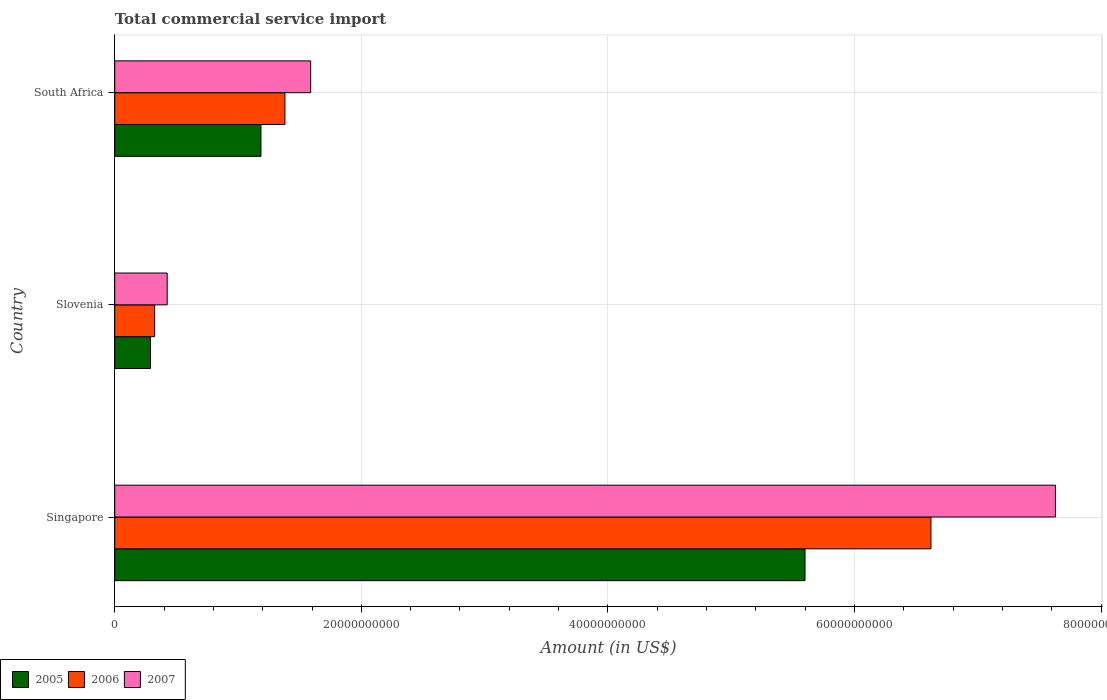How many different coloured bars are there?
Your answer should be compact. 3. Are the number of bars per tick equal to the number of legend labels?
Provide a short and direct response. Yes. How many bars are there on the 3rd tick from the bottom?
Your answer should be very brief. 3. What is the label of the 2nd group of bars from the top?
Ensure brevity in your answer.  Slovenia. In how many cases, is the number of bars for a given country not equal to the number of legend labels?
Ensure brevity in your answer.  0. What is the total commercial service import in 2007 in Singapore?
Keep it short and to the point. 7.63e+1. Across all countries, what is the maximum total commercial service import in 2006?
Offer a terse response. 6.62e+1. Across all countries, what is the minimum total commercial service import in 2007?
Your response must be concise. 4.25e+09. In which country was the total commercial service import in 2006 maximum?
Offer a very short reply. Singapore. In which country was the total commercial service import in 2005 minimum?
Provide a succinct answer. Slovenia. What is the total total commercial service import in 2005 in the graph?
Your answer should be compact. 7.07e+1. What is the difference between the total commercial service import in 2007 in Singapore and that in South Africa?
Keep it short and to the point. 6.04e+1. What is the difference between the total commercial service import in 2007 in Singapore and the total commercial service import in 2005 in Slovenia?
Offer a very short reply. 7.34e+1. What is the average total commercial service import in 2005 per country?
Ensure brevity in your answer.  2.36e+1. What is the difference between the total commercial service import in 2006 and total commercial service import in 2005 in South Africa?
Your response must be concise. 1.94e+09. In how many countries, is the total commercial service import in 2005 greater than 4000000000 US$?
Ensure brevity in your answer.  2. What is the ratio of the total commercial service import in 2005 in Singapore to that in South Africa?
Offer a terse response. 4.72. What is the difference between the highest and the second highest total commercial service import in 2006?
Your answer should be very brief. 5.24e+1. What is the difference between the highest and the lowest total commercial service import in 2005?
Your answer should be very brief. 5.31e+1. In how many countries, is the total commercial service import in 2006 greater than the average total commercial service import in 2006 taken over all countries?
Give a very brief answer. 1. Is the sum of the total commercial service import in 2007 in Slovenia and South Africa greater than the maximum total commercial service import in 2005 across all countries?
Offer a very short reply. No. What does the 1st bar from the bottom in Singapore represents?
Make the answer very short. 2005. Is it the case that in every country, the sum of the total commercial service import in 2007 and total commercial service import in 2006 is greater than the total commercial service import in 2005?
Your answer should be very brief. Yes. Are all the bars in the graph horizontal?
Provide a succinct answer. Yes. What is the difference between two consecutive major ticks on the X-axis?
Your answer should be compact. 2.00e+1. Are the values on the major ticks of X-axis written in scientific E-notation?
Your answer should be very brief. No. Does the graph contain any zero values?
Offer a very short reply. No. Does the graph contain grids?
Provide a succinct answer. Yes. What is the title of the graph?
Your answer should be very brief. Total commercial service import. Does "2014" appear as one of the legend labels in the graph?
Keep it short and to the point. No. What is the label or title of the X-axis?
Your answer should be compact. Amount (in US$). What is the label or title of the Y-axis?
Make the answer very short. Country. What is the Amount (in US$) of 2005 in Singapore?
Your answer should be compact. 5.60e+1. What is the Amount (in US$) in 2006 in Singapore?
Offer a terse response. 6.62e+1. What is the Amount (in US$) of 2007 in Singapore?
Provide a succinct answer. 7.63e+1. What is the Amount (in US$) of 2005 in Slovenia?
Provide a short and direct response. 2.90e+09. What is the Amount (in US$) of 2006 in Slovenia?
Your answer should be very brief. 3.24e+09. What is the Amount (in US$) in 2007 in Slovenia?
Make the answer very short. 4.25e+09. What is the Amount (in US$) of 2005 in South Africa?
Your answer should be very brief. 1.19e+1. What is the Amount (in US$) in 2006 in South Africa?
Ensure brevity in your answer.  1.38e+1. What is the Amount (in US$) of 2007 in South Africa?
Provide a succinct answer. 1.59e+1. Across all countries, what is the maximum Amount (in US$) in 2005?
Give a very brief answer. 5.60e+1. Across all countries, what is the maximum Amount (in US$) of 2006?
Give a very brief answer. 6.62e+1. Across all countries, what is the maximum Amount (in US$) in 2007?
Make the answer very short. 7.63e+1. Across all countries, what is the minimum Amount (in US$) of 2005?
Give a very brief answer. 2.90e+09. Across all countries, what is the minimum Amount (in US$) of 2006?
Your response must be concise. 3.24e+09. Across all countries, what is the minimum Amount (in US$) of 2007?
Provide a succinct answer. 4.25e+09. What is the total Amount (in US$) of 2005 in the graph?
Offer a very short reply. 7.07e+1. What is the total Amount (in US$) in 2006 in the graph?
Keep it short and to the point. 8.32e+1. What is the total Amount (in US$) of 2007 in the graph?
Offer a terse response. 9.64e+1. What is the difference between the Amount (in US$) in 2005 in Singapore and that in Slovenia?
Ensure brevity in your answer.  5.31e+1. What is the difference between the Amount (in US$) of 2006 in Singapore and that in Slovenia?
Offer a terse response. 6.30e+1. What is the difference between the Amount (in US$) of 2007 in Singapore and that in Slovenia?
Make the answer very short. 7.20e+1. What is the difference between the Amount (in US$) in 2005 in Singapore and that in South Africa?
Your answer should be very brief. 4.41e+1. What is the difference between the Amount (in US$) of 2006 in Singapore and that in South Africa?
Offer a very short reply. 5.24e+1. What is the difference between the Amount (in US$) of 2007 in Singapore and that in South Africa?
Your answer should be very brief. 6.04e+1. What is the difference between the Amount (in US$) of 2005 in Slovenia and that in South Africa?
Make the answer very short. -8.96e+09. What is the difference between the Amount (in US$) in 2006 in Slovenia and that in South Africa?
Provide a succinct answer. -1.06e+1. What is the difference between the Amount (in US$) in 2007 in Slovenia and that in South Africa?
Your answer should be very brief. -1.16e+1. What is the difference between the Amount (in US$) of 2005 in Singapore and the Amount (in US$) of 2006 in Slovenia?
Provide a succinct answer. 5.27e+1. What is the difference between the Amount (in US$) of 2005 in Singapore and the Amount (in US$) of 2007 in Slovenia?
Your response must be concise. 5.17e+1. What is the difference between the Amount (in US$) of 2006 in Singapore and the Amount (in US$) of 2007 in Slovenia?
Ensure brevity in your answer.  6.19e+1. What is the difference between the Amount (in US$) of 2005 in Singapore and the Amount (in US$) of 2006 in South Africa?
Your answer should be compact. 4.22e+1. What is the difference between the Amount (in US$) of 2005 in Singapore and the Amount (in US$) of 2007 in South Africa?
Your answer should be compact. 4.01e+1. What is the difference between the Amount (in US$) in 2006 in Singapore and the Amount (in US$) in 2007 in South Africa?
Keep it short and to the point. 5.03e+1. What is the difference between the Amount (in US$) in 2005 in Slovenia and the Amount (in US$) in 2006 in South Africa?
Ensure brevity in your answer.  -1.09e+1. What is the difference between the Amount (in US$) in 2005 in Slovenia and the Amount (in US$) in 2007 in South Africa?
Make the answer very short. -1.30e+1. What is the difference between the Amount (in US$) of 2006 in Slovenia and the Amount (in US$) of 2007 in South Africa?
Your response must be concise. -1.27e+1. What is the average Amount (in US$) of 2005 per country?
Your response must be concise. 2.36e+1. What is the average Amount (in US$) in 2006 per country?
Make the answer very short. 2.77e+1. What is the average Amount (in US$) in 2007 per country?
Your response must be concise. 3.21e+1. What is the difference between the Amount (in US$) in 2005 and Amount (in US$) in 2006 in Singapore?
Offer a very short reply. -1.02e+1. What is the difference between the Amount (in US$) in 2005 and Amount (in US$) in 2007 in Singapore?
Provide a succinct answer. -2.03e+1. What is the difference between the Amount (in US$) of 2006 and Amount (in US$) of 2007 in Singapore?
Provide a succinct answer. -1.01e+1. What is the difference between the Amount (in US$) in 2005 and Amount (in US$) in 2006 in Slovenia?
Offer a terse response. -3.36e+08. What is the difference between the Amount (in US$) of 2005 and Amount (in US$) of 2007 in Slovenia?
Ensure brevity in your answer.  -1.35e+09. What is the difference between the Amount (in US$) in 2006 and Amount (in US$) in 2007 in Slovenia?
Provide a short and direct response. -1.02e+09. What is the difference between the Amount (in US$) in 2005 and Amount (in US$) in 2006 in South Africa?
Provide a succinct answer. -1.94e+09. What is the difference between the Amount (in US$) in 2005 and Amount (in US$) in 2007 in South Africa?
Give a very brief answer. -4.03e+09. What is the difference between the Amount (in US$) in 2006 and Amount (in US$) in 2007 in South Africa?
Provide a succinct answer. -2.09e+09. What is the ratio of the Amount (in US$) of 2005 in Singapore to that in Slovenia?
Offer a terse response. 19.31. What is the ratio of the Amount (in US$) of 2006 in Singapore to that in Slovenia?
Your answer should be very brief. 20.46. What is the ratio of the Amount (in US$) of 2007 in Singapore to that in Slovenia?
Provide a short and direct response. 17.94. What is the ratio of the Amount (in US$) in 2005 in Singapore to that in South Africa?
Give a very brief answer. 4.72. What is the ratio of the Amount (in US$) in 2006 in Singapore to that in South Africa?
Keep it short and to the point. 4.8. What is the ratio of the Amount (in US$) of 2007 in Singapore to that in South Africa?
Your response must be concise. 4.8. What is the ratio of the Amount (in US$) in 2005 in Slovenia to that in South Africa?
Ensure brevity in your answer.  0.24. What is the ratio of the Amount (in US$) of 2006 in Slovenia to that in South Africa?
Your answer should be compact. 0.23. What is the ratio of the Amount (in US$) in 2007 in Slovenia to that in South Africa?
Keep it short and to the point. 0.27. What is the difference between the highest and the second highest Amount (in US$) of 2005?
Your answer should be very brief. 4.41e+1. What is the difference between the highest and the second highest Amount (in US$) in 2006?
Make the answer very short. 5.24e+1. What is the difference between the highest and the second highest Amount (in US$) in 2007?
Your answer should be very brief. 6.04e+1. What is the difference between the highest and the lowest Amount (in US$) of 2005?
Ensure brevity in your answer.  5.31e+1. What is the difference between the highest and the lowest Amount (in US$) in 2006?
Your response must be concise. 6.30e+1. What is the difference between the highest and the lowest Amount (in US$) of 2007?
Your answer should be compact. 7.20e+1. 